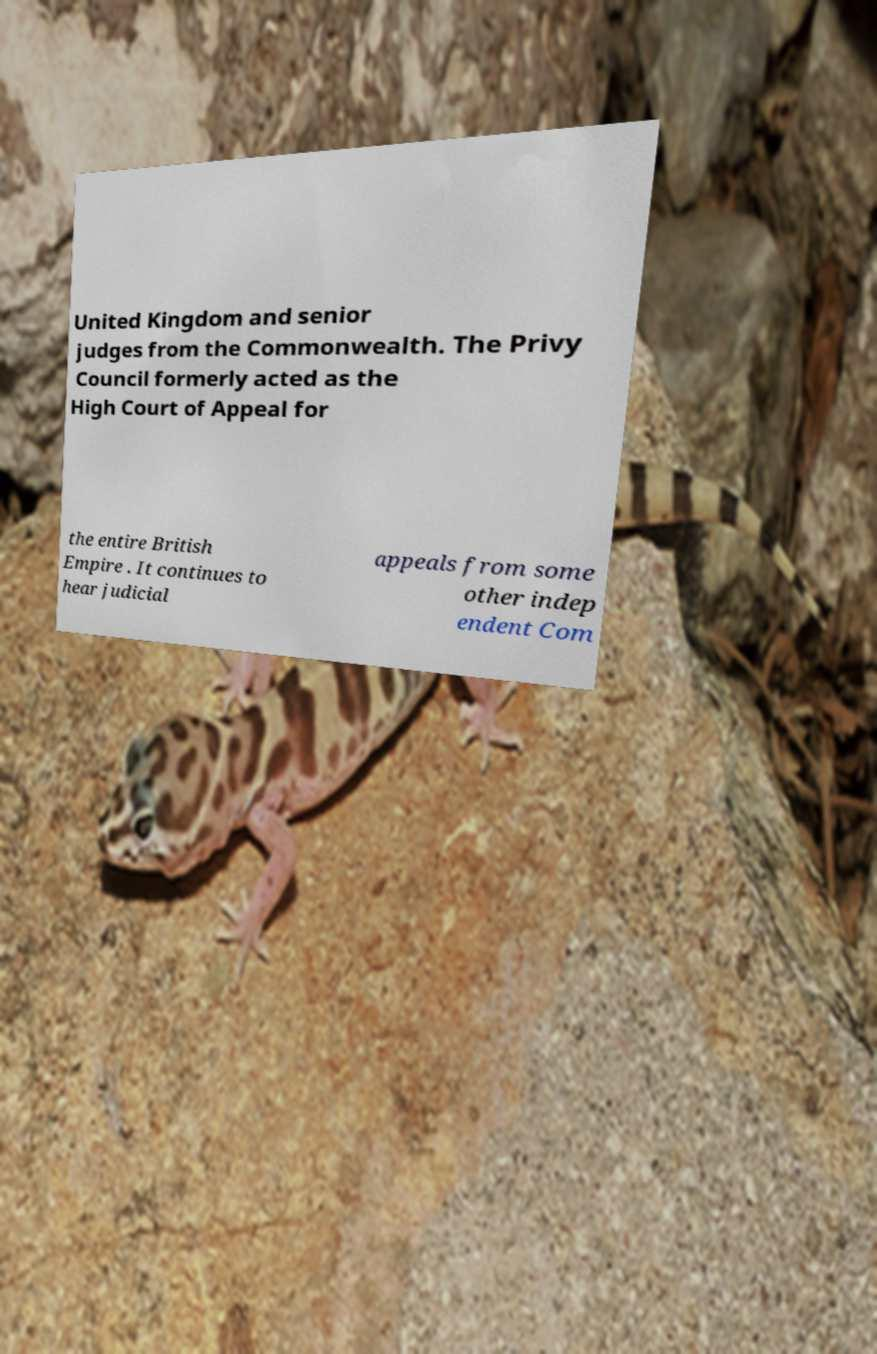Please read and relay the text visible in this image. What does it say? United Kingdom and senior judges from the Commonwealth. The Privy Council formerly acted as the High Court of Appeal for the entire British Empire . It continues to hear judicial appeals from some other indep endent Com 